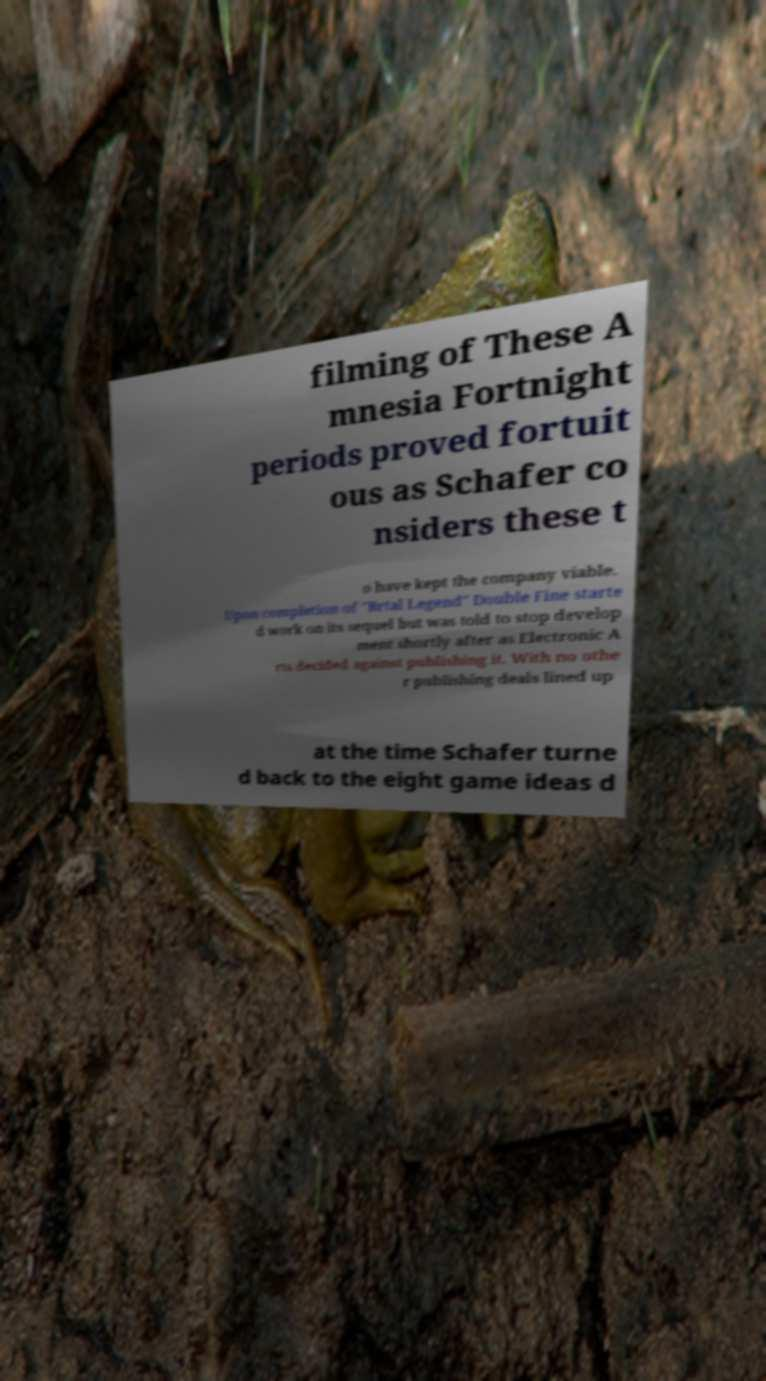What messages or text are displayed in this image? I need them in a readable, typed format. filming of These A mnesia Fortnight periods proved fortuit ous as Schafer co nsiders these t o have kept the company viable. Upon completion of "Brtal Legend" Double Fine starte d work on its sequel but was told to stop develop ment shortly after as Electronic A rts decided against publishing it. With no othe r publishing deals lined up at the time Schafer turne d back to the eight game ideas d 